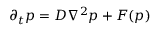<formula> <loc_0><loc_0><loc_500><loc_500>\partial _ { t } p = D \nabla ^ { 2 } p + F ( p )</formula> 